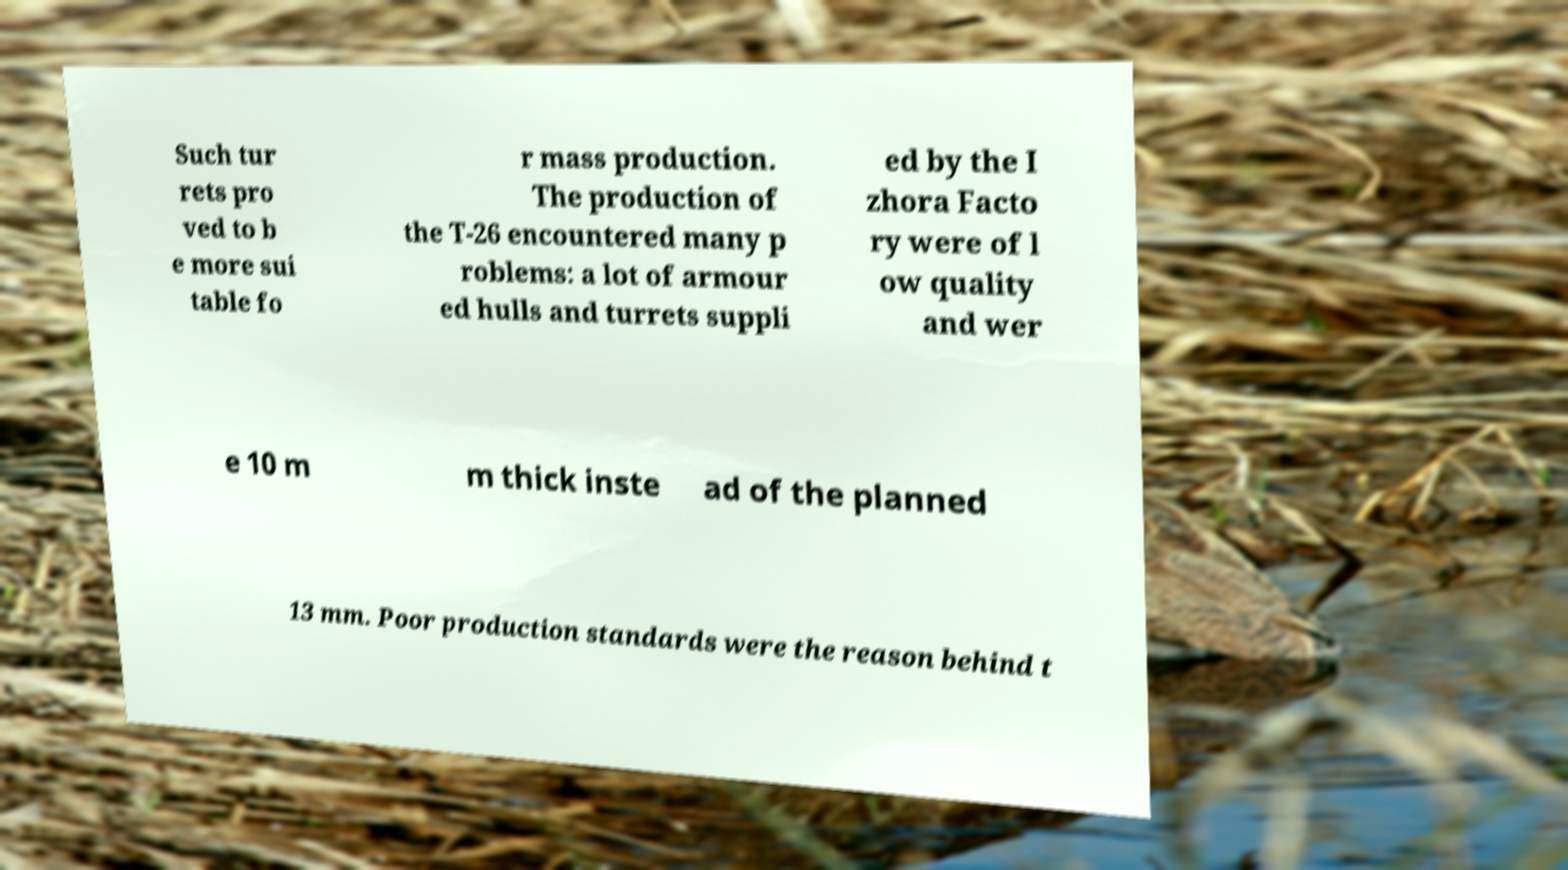Could you extract and type out the text from this image? Such tur rets pro ved to b e more sui table fo r mass production. The production of the T-26 encountered many p roblems: a lot of armour ed hulls and turrets suppli ed by the I zhora Facto ry were of l ow quality and wer e 10 m m thick inste ad of the planned 13 mm. Poor production standards were the reason behind t 